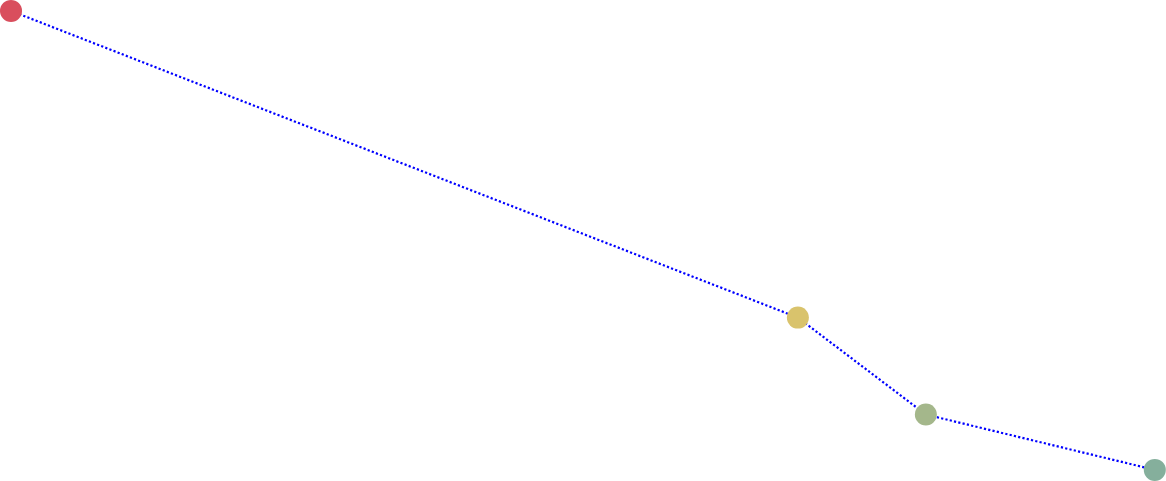Convert chart to OTSL. <chart><loc_0><loc_0><loc_500><loc_500><line_chart><ecel><fcel>Unnamed: 1<nl><fcel>1625.25<fcel>156.02<nl><fcel>2058.79<fcel>98.51<nl><fcel>2129.31<fcel>80.34<nl><fcel>2255.44<fcel>69.96<nl><fcel>2330.49<fcel>52.19<nl></chart> 